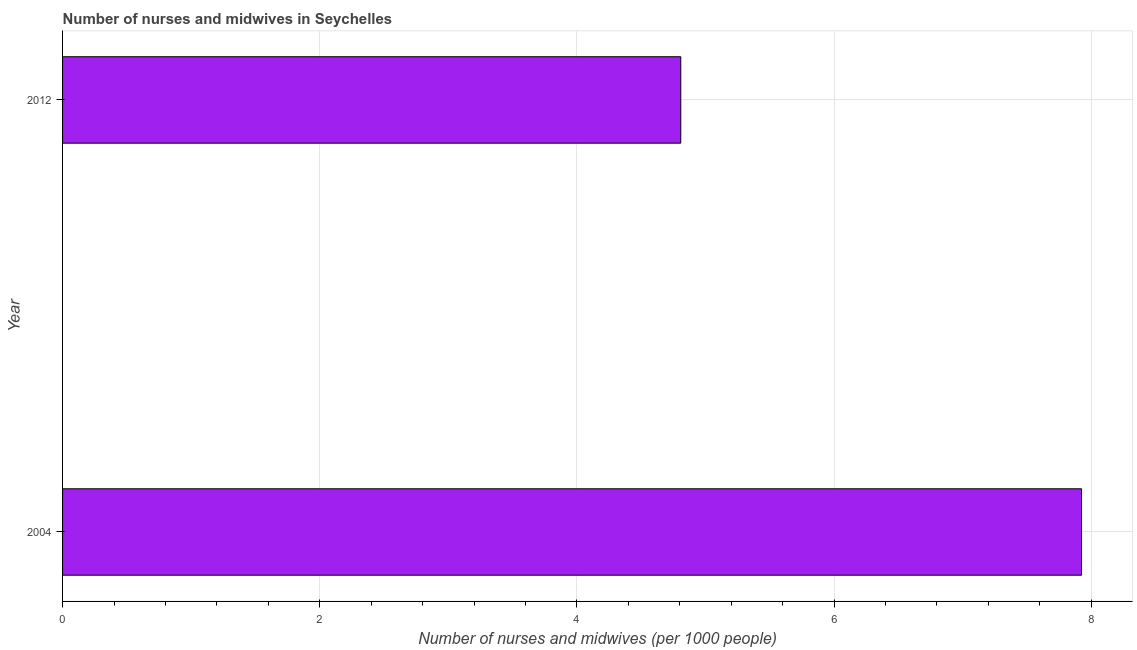Does the graph contain any zero values?
Ensure brevity in your answer.  No. Does the graph contain grids?
Make the answer very short. Yes. What is the title of the graph?
Keep it short and to the point. Number of nurses and midwives in Seychelles. What is the label or title of the X-axis?
Ensure brevity in your answer.  Number of nurses and midwives (per 1000 people). What is the label or title of the Y-axis?
Your answer should be compact. Year. What is the number of nurses and midwives in 2004?
Offer a terse response. 7.92. Across all years, what is the maximum number of nurses and midwives?
Offer a very short reply. 7.92. Across all years, what is the minimum number of nurses and midwives?
Offer a terse response. 4.81. In which year was the number of nurses and midwives maximum?
Your answer should be compact. 2004. What is the sum of the number of nurses and midwives?
Make the answer very short. 12.73. What is the difference between the number of nurses and midwives in 2004 and 2012?
Make the answer very short. 3.12. What is the average number of nurses and midwives per year?
Give a very brief answer. 6.37. What is the median number of nurses and midwives?
Make the answer very short. 6.37. In how many years, is the number of nurses and midwives greater than 6.4 ?
Provide a short and direct response. 1. What is the ratio of the number of nurses and midwives in 2004 to that in 2012?
Provide a succinct answer. 1.65. Is the number of nurses and midwives in 2004 less than that in 2012?
Offer a terse response. No. In how many years, is the number of nurses and midwives greater than the average number of nurses and midwives taken over all years?
Provide a succinct answer. 1. How many bars are there?
Give a very brief answer. 2. Are all the bars in the graph horizontal?
Provide a succinct answer. Yes. What is the difference between two consecutive major ticks on the X-axis?
Your response must be concise. 2. Are the values on the major ticks of X-axis written in scientific E-notation?
Your answer should be very brief. No. What is the Number of nurses and midwives (per 1000 people) in 2004?
Offer a terse response. 7.92. What is the Number of nurses and midwives (per 1000 people) in 2012?
Provide a short and direct response. 4.81. What is the difference between the Number of nurses and midwives (per 1000 people) in 2004 and 2012?
Make the answer very short. 3.12. What is the ratio of the Number of nurses and midwives (per 1000 people) in 2004 to that in 2012?
Keep it short and to the point. 1.65. 